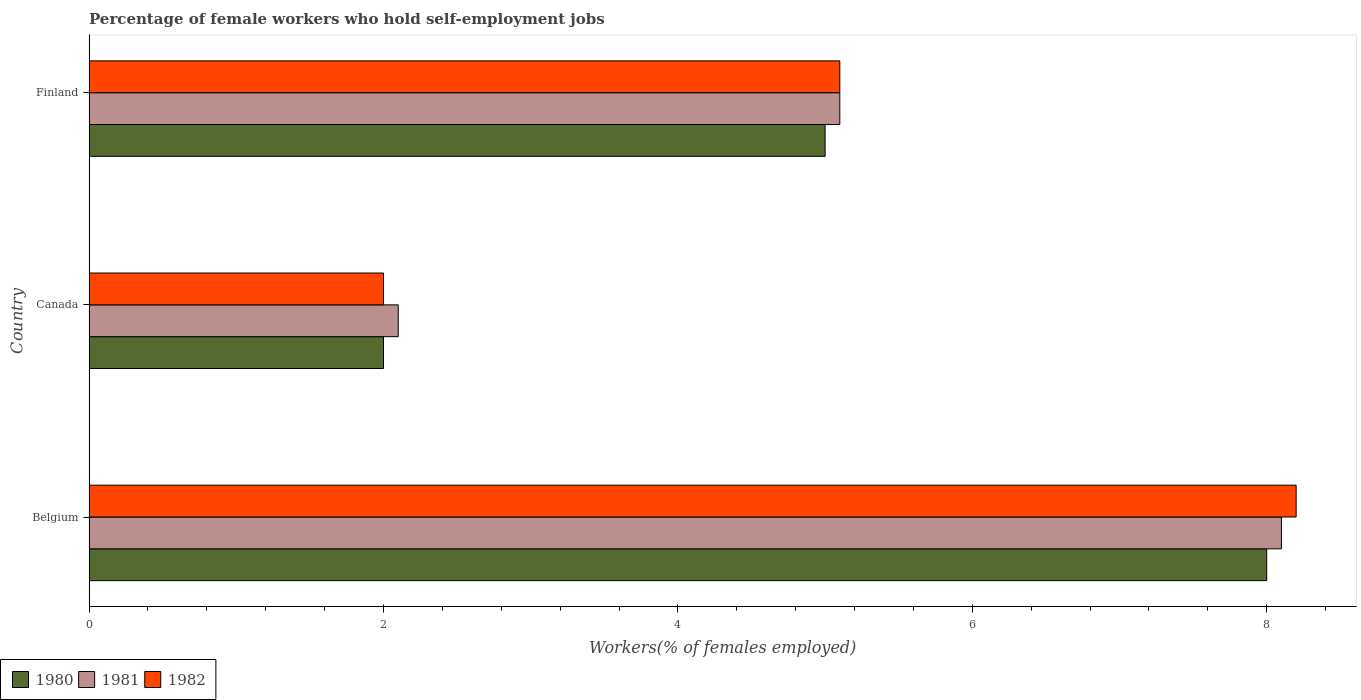How many different coloured bars are there?
Your response must be concise. 3. How many groups of bars are there?
Ensure brevity in your answer.  3. Are the number of bars per tick equal to the number of legend labels?
Provide a succinct answer. Yes. What is the label of the 1st group of bars from the top?
Keep it short and to the point. Finland. What is the percentage of self-employed female workers in 1982 in Finland?
Your response must be concise. 5.1. What is the total percentage of self-employed female workers in 1981 in the graph?
Offer a very short reply. 15.3. What is the difference between the percentage of self-employed female workers in 1982 in Belgium and that in Canada?
Provide a succinct answer. 6.2. What is the difference between the percentage of self-employed female workers in 1980 in Canada and the percentage of self-employed female workers in 1981 in Belgium?
Provide a short and direct response. -6.1. In how many countries, is the percentage of self-employed female workers in 1982 greater than 0.8 %?
Make the answer very short. 3. What is the ratio of the percentage of self-employed female workers in 1982 in Canada to that in Finland?
Offer a very short reply. 0.39. Is the difference between the percentage of self-employed female workers in 1982 in Belgium and Finland greater than the difference between the percentage of self-employed female workers in 1981 in Belgium and Finland?
Offer a terse response. Yes. What is the difference between the highest and the second highest percentage of self-employed female workers in 1980?
Give a very brief answer. 3. What is the difference between the highest and the lowest percentage of self-employed female workers in 1981?
Offer a very short reply. 6. Is the sum of the percentage of self-employed female workers in 1981 in Belgium and Canada greater than the maximum percentage of self-employed female workers in 1982 across all countries?
Provide a succinct answer. Yes. Is it the case that in every country, the sum of the percentage of self-employed female workers in 1980 and percentage of self-employed female workers in 1981 is greater than the percentage of self-employed female workers in 1982?
Keep it short and to the point. Yes. How many bars are there?
Give a very brief answer. 9. Are the values on the major ticks of X-axis written in scientific E-notation?
Offer a terse response. No. Does the graph contain any zero values?
Give a very brief answer. No. Where does the legend appear in the graph?
Your response must be concise. Bottom left. What is the title of the graph?
Keep it short and to the point. Percentage of female workers who hold self-employment jobs. Does "1983" appear as one of the legend labels in the graph?
Provide a short and direct response. No. What is the label or title of the X-axis?
Provide a succinct answer. Workers(% of females employed). What is the Workers(% of females employed) of 1981 in Belgium?
Offer a terse response. 8.1. What is the Workers(% of females employed) in 1982 in Belgium?
Your answer should be compact. 8.2. What is the Workers(% of females employed) of 1980 in Canada?
Offer a terse response. 2. What is the Workers(% of females employed) in 1981 in Canada?
Offer a terse response. 2.1. What is the Workers(% of females employed) in 1982 in Canada?
Your response must be concise. 2. What is the Workers(% of females employed) in 1980 in Finland?
Keep it short and to the point. 5. What is the Workers(% of females employed) of 1981 in Finland?
Give a very brief answer. 5.1. What is the Workers(% of females employed) in 1982 in Finland?
Provide a succinct answer. 5.1. Across all countries, what is the maximum Workers(% of females employed) of 1980?
Ensure brevity in your answer.  8. Across all countries, what is the maximum Workers(% of females employed) in 1981?
Your answer should be very brief. 8.1. Across all countries, what is the maximum Workers(% of females employed) in 1982?
Offer a very short reply. 8.2. Across all countries, what is the minimum Workers(% of females employed) of 1981?
Make the answer very short. 2.1. Across all countries, what is the minimum Workers(% of females employed) in 1982?
Your answer should be compact. 2. What is the difference between the Workers(% of females employed) in 1980 in Belgium and that in Canada?
Your answer should be compact. 6. What is the difference between the Workers(% of females employed) in 1981 in Belgium and that in Canada?
Offer a terse response. 6. What is the difference between the Workers(% of females employed) of 1980 in Belgium and that in Finland?
Give a very brief answer. 3. What is the difference between the Workers(% of females employed) of 1981 in Belgium and the Workers(% of females employed) of 1982 in Canada?
Offer a terse response. 6.1. What is the difference between the Workers(% of females employed) in 1980 in Canada and the Workers(% of females employed) in 1981 in Finland?
Offer a very short reply. -3.1. What is the average Workers(% of females employed) in 1980 per country?
Give a very brief answer. 5. What is the average Workers(% of females employed) of 1981 per country?
Ensure brevity in your answer.  5.1. What is the average Workers(% of females employed) of 1982 per country?
Offer a terse response. 5.1. What is the difference between the Workers(% of females employed) in 1981 and Workers(% of females employed) in 1982 in Belgium?
Offer a very short reply. -0.1. What is the difference between the Workers(% of females employed) in 1980 and Workers(% of females employed) in 1982 in Canada?
Keep it short and to the point. 0. What is the difference between the Workers(% of females employed) of 1981 and Workers(% of females employed) of 1982 in Canada?
Provide a succinct answer. 0.1. What is the difference between the Workers(% of females employed) in 1981 and Workers(% of females employed) in 1982 in Finland?
Keep it short and to the point. 0. What is the ratio of the Workers(% of females employed) of 1981 in Belgium to that in Canada?
Offer a terse response. 3.86. What is the ratio of the Workers(% of females employed) in 1982 in Belgium to that in Canada?
Ensure brevity in your answer.  4.1. What is the ratio of the Workers(% of females employed) of 1980 in Belgium to that in Finland?
Your response must be concise. 1.6. What is the ratio of the Workers(% of females employed) of 1981 in Belgium to that in Finland?
Offer a very short reply. 1.59. What is the ratio of the Workers(% of females employed) in 1982 in Belgium to that in Finland?
Keep it short and to the point. 1.61. What is the ratio of the Workers(% of females employed) in 1980 in Canada to that in Finland?
Your answer should be compact. 0.4. What is the ratio of the Workers(% of females employed) in 1981 in Canada to that in Finland?
Offer a terse response. 0.41. What is the ratio of the Workers(% of females employed) in 1982 in Canada to that in Finland?
Your answer should be very brief. 0.39. What is the difference between the highest and the second highest Workers(% of females employed) of 1981?
Ensure brevity in your answer.  3. What is the difference between the highest and the lowest Workers(% of females employed) of 1982?
Offer a terse response. 6.2. 